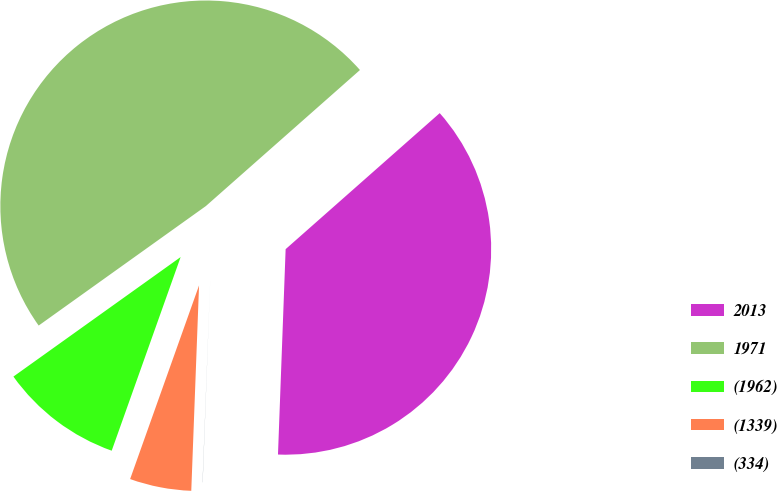Convert chart to OTSL. <chart><loc_0><loc_0><loc_500><loc_500><pie_chart><fcel>2013<fcel>1971<fcel>(1962)<fcel>(1339)<fcel>(334)<nl><fcel>37.1%<fcel>48.36%<fcel>9.68%<fcel>4.84%<fcel>0.01%<nl></chart> 